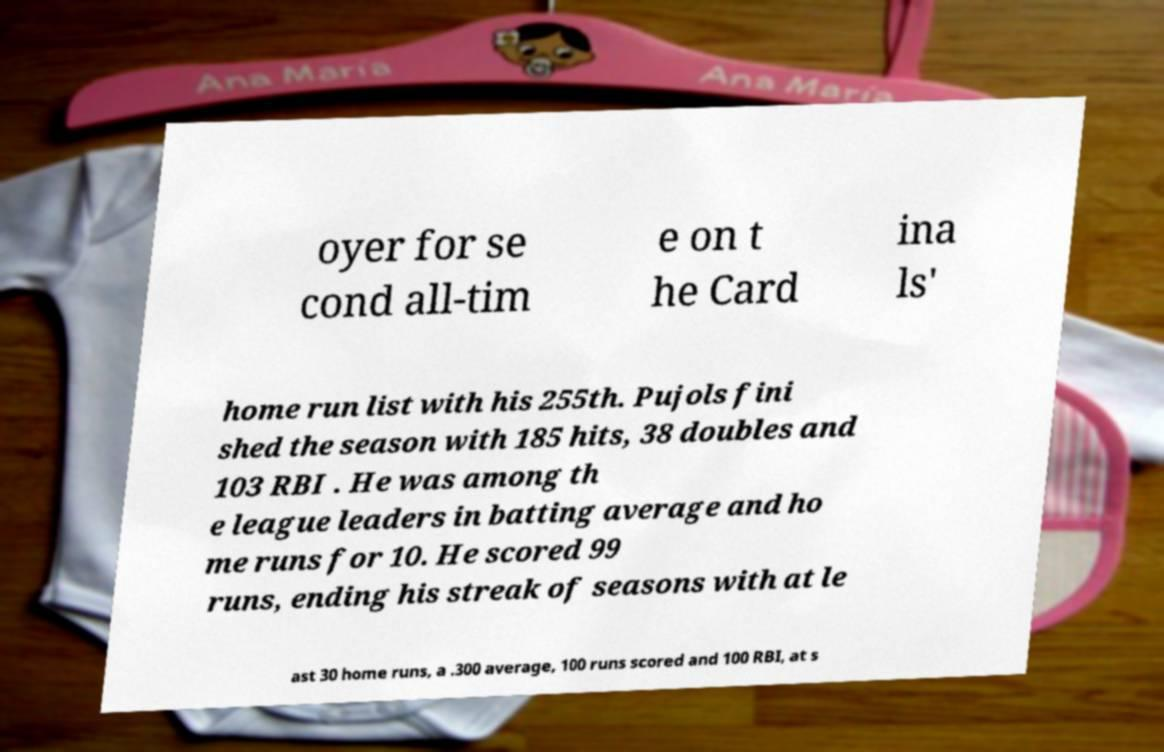Can you read and provide the text displayed in the image?This photo seems to have some interesting text. Can you extract and type it out for me? oyer for se cond all-tim e on t he Card ina ls' home run list with his 255th. Pujols fini shed the season with 185 hits, 38 doubles and 103 RBI . He was among th e league leaders in batting average and ho me runs for 10. He scored 99 runs, ending his streak of seasons with at le ast 30 home runs, a .300 average, 100 runs scored and 100 RBI, at s 